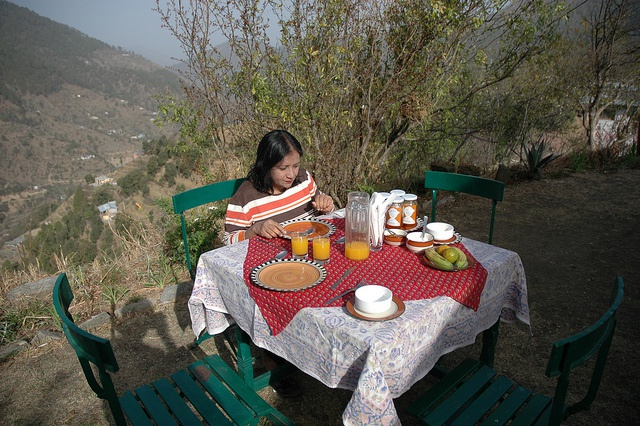Describe the objects in this image and their specific colors. I can see dining table in purple, darkgray, lightgray, gray, and brown tones, chair in purple, black, teal, gray, and darkgreen tones, chair in purple, black, and darkblue tones, people in purple, black, brown, white, and gray tones, and chair in purple, black, teal, and darkgreen tones in this image. 